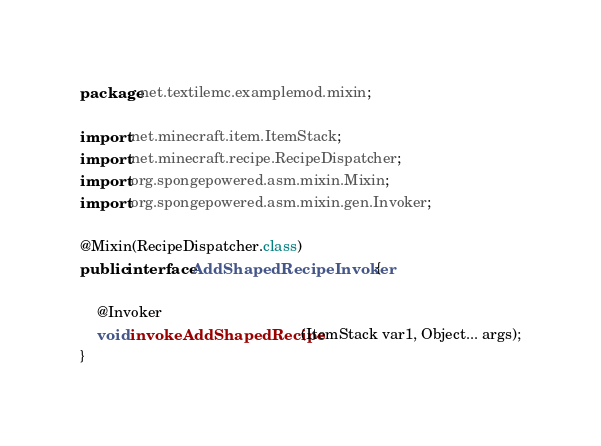<code> <loc_0><loc_0><loc_500><loc_500><_Java_>package net.textilemc.examplemod.mixin;

import net.minecraft.item.ItemStack;
import net.minecraft.recipe.RecipeDispatcher;
import org.spongepowered.asm.mixin.Mixin;
import org.spongepowered.asm.mixin.gen.Invoker;

@Mixin(RecipeDispatcher.class)
public interface AddShapedRecipeInvoker {

    @Invoker
    void invokeAddShapedRecipe(ItemStack var1, Object... args);
}
</code> 